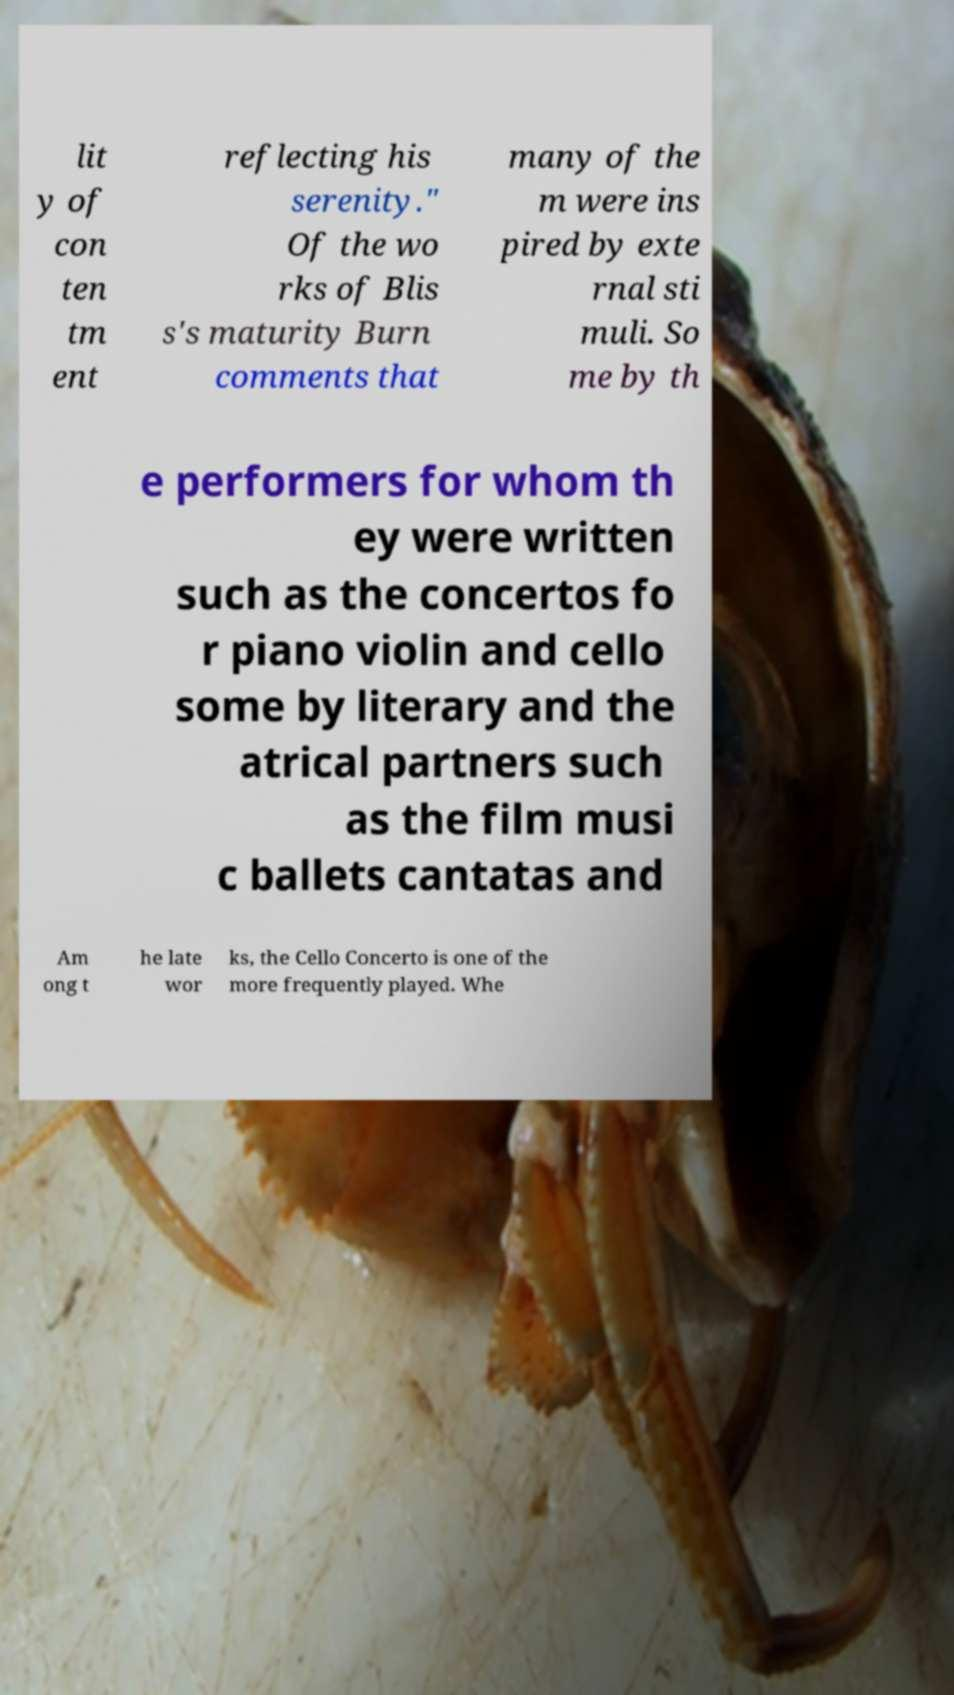I need the written content from this picture converted into text. Can you do that? lit y of con ten tm ent reflecting his serenity." Of the wo rks of Blis s's maturity Burn comments that many of the m were ins pired by exte rnal sti muli. So me by th e performers for whom th ey were written such as the concertos fo r piano violin and cello some by literary and the atrical partners such as the film musi c ballets cantatas and Am ong t he late wor ks, the Cello Concerto is one of the more frequently played. Whe 